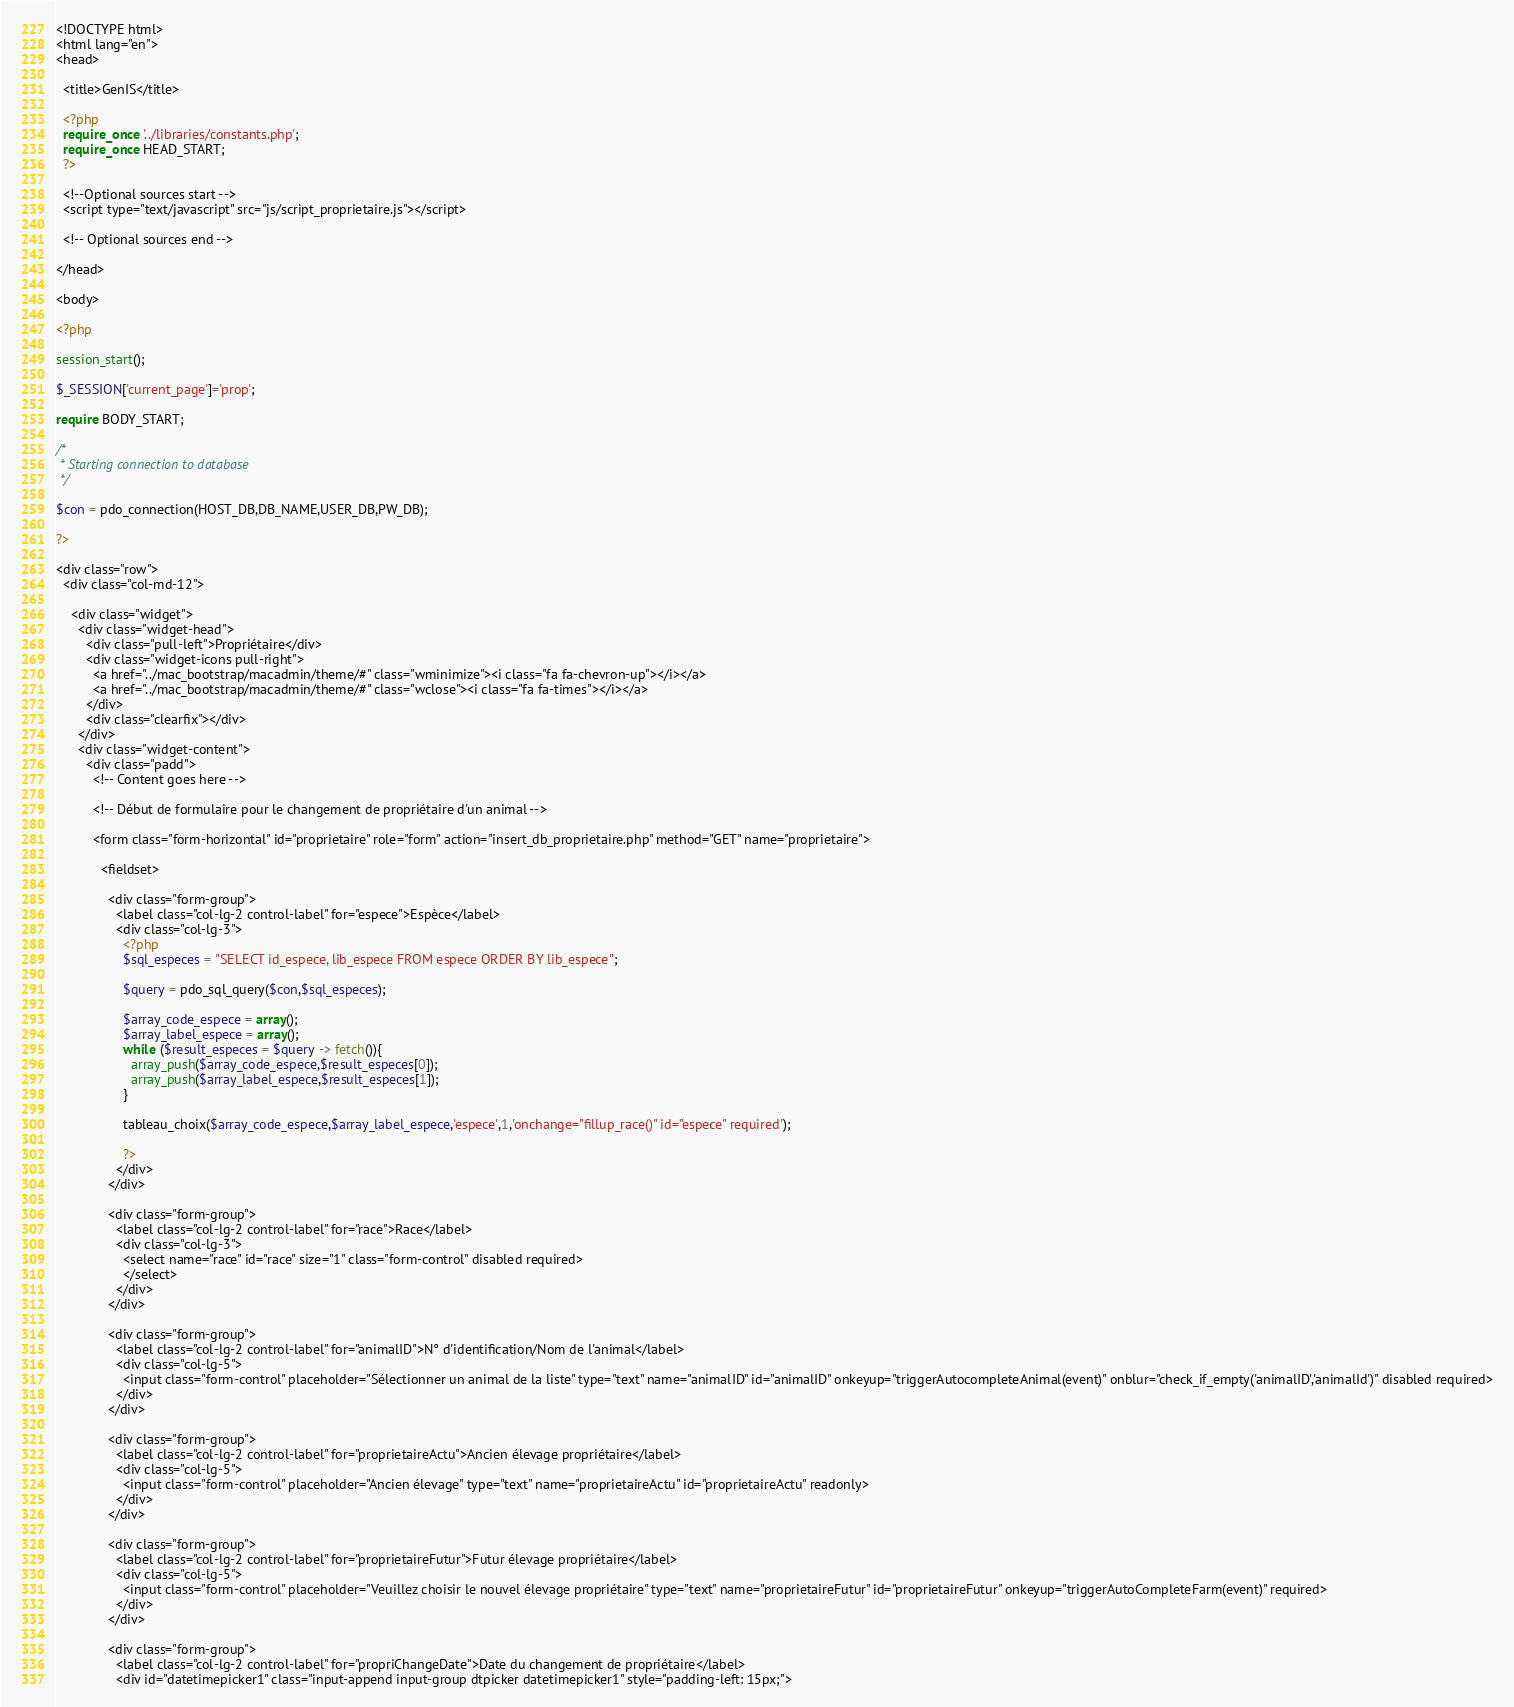<code> <loc_0><loc_0><loc_500><loc_500><_PHP_><!DOCTYPE html>
<html lang="en">
<head>

  <title>GenIS</title>

  <?php 
  require_once '../libraries/constants.php';
  require_once HEAD_START;
  ?>

  <!--Optional sources start -->
  <script type="text/javascript" src="js/script_proprietaire.js"></script>

  <!-- Optional sources end -->

</head>

<body>

<?php

session_start();

$_SESSION['current_page']='prop';

require BODY_START;

/*
 * Starting connection to database
 */

$con = pdo_connection(HOST_DB,DB_NAME,USER_DB,PW_DB);

?>

<div class="row">
  <div class="col-md-12">

    <div class="widget">
      <div class="widget-head">
        <div class="pull-left">Propriétaire</div>
        <div class="widget-icons pull-right">
          <a href="../mac_bootstrap/macadmin/theme/#" class="wminimize"><i class="fa fa-chevron-up"></i></a>
          <a href="../mac_bootstrap/macadmin/theme/#" class="wclose"><i class="fa fa-times"></i></a>
        </div>
        <div class="clearfix"></div>
      </div>
      <div class="widget-content">
        <div class="padd">
          <!-- Content goes here -->

          <!-- Début de formulaire pour le changement de propriétaire d'un animal -->

          <form class="form-horizontal" id="proprietaire" role="form" action="insert_db_proprietaire.php" method="GET" name="proprietaire">

            <fieldset>

              <div class="form-group">
                <label class="col-lg-2 control-label" for="espece">Espèce</label>
                <div class="col-lg-3">
                  <?php
                  $sql_especes = "SELECT id_espece, lib_espece FROM espece ORDER BY lib_espece";

                  $query = pdo_sql_query($con,$sql_especes);

                  $array_code_espece = array();
                  $array_label_espece = array();
                  while ($result_especes = $query -> fetch()){
                    array_push($array_code_espece,$result_especes[0]);
                    array_push($array_label_espece,$result_especes[1]);
                  }

                  tableau_choix($array_code_espece,$array_label_espece,'espece',1,'onchange="fillup_race()" id="espece" required');

                  ?>
                </div>
              </div>

              <div class="form-group">
                <label class="col-lg-2 control-label" for="race">Race</label>
                <div class="col-lg-3">
                  <select name="race" id="race" size="1" class="form-control" disabled required>
                  </select>
                </div>
              </div>

              <div class="form-group">
                <label class="col-lg-2 control-label" for="animalID">N° d'identification/Nom de l'animal</label>
                <div class="col-lg-5">
                  <input class="form-control" placeholder="Sélectionner un animal de la liste" type="text" name="animalID" id="animalID" onkeyup="triggerAutocompleteAnimal(event)" onblur="check_if_empty('animalID','animalId')" disabled required>
                </div>
              </div>

              <div class="form-group">
                <label class="col-lg-2 control-label" for="proprietaireActu">Ancien élevage propriétaire</label>
                <div class="col-lg-5">
                  <input class="form-control" placeholder="Ancien élevage" type="text" name="proprietaireActu" id="proprietaireActu" readonly>
                </div>
              </div>

              <div class="form-group">
                <label class="col-lg-2 control-label" for="proprietaireFutur">Futur élevage propriétaire</label>
                <div class="col-lg-5">
                  <input class="form-control" placeholder="Veuillez choisir le nouvel élevage propriétaire" type="text" name="proprietaireFutur" id="proprietaireFutur" onkeyup="triggerAutoCompleteFarm(event)" required>
                </div>
              </div>

              <div class="form-group">
                <label class="col-lg-2 control-label" for="propriChangeDate">Date du changement de propriétaire</label>
                <div id="datetimepicker1" class="input-append input-group dtpicker datetimepicker1" style="padding-left: 15px;"></code> 